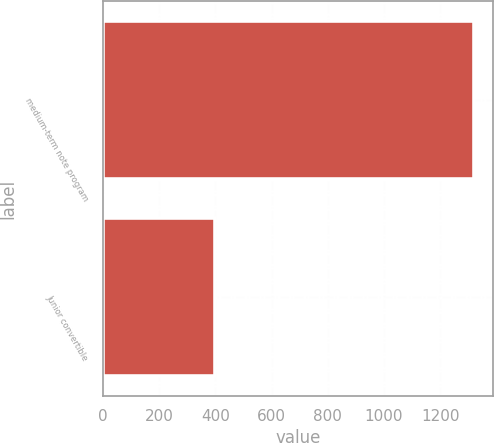Convert chart to OTSL. <chart><loc_0><loc_0><loc_500><loc_500><bar_chart><fcel>medium-term note program<fcel>Junior convertible<nl><fcel>1321.7<fcel>398.1<nl></chart> 